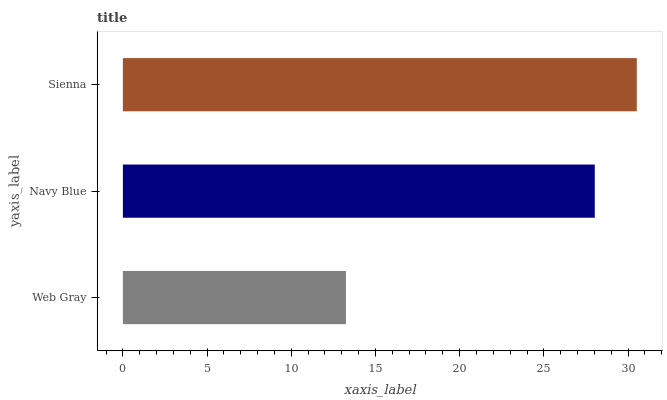Is Web Gray the minimum?
Answer yes or no. Yes. Is Sienna the maximum?
Answer yes or no. Yes. Is Navy Blue the minimum?
Answer yes or no. No. Is Navy Blue the maximum?
Answer yes or no. No. Is Navy Blue greater than Web Gray?
Answer yes or no. Yes. Is Web Gray less than Navy Blue?
Answer yes or no. Yes. Is Web Gray greater than Navy Blue?
Answer yes or no. No. Is Navy Blue less than Web Gray?
Answer yes or no. No. Is Navy Blue the high median?
Answer yes or no. Yes. Is Navy Blue the low median?
Answer yes or no. Yes. Is Web Gray the high median?
Answer yes or no. No. Is Web Gray the low median?
Answer yes or no. No. 